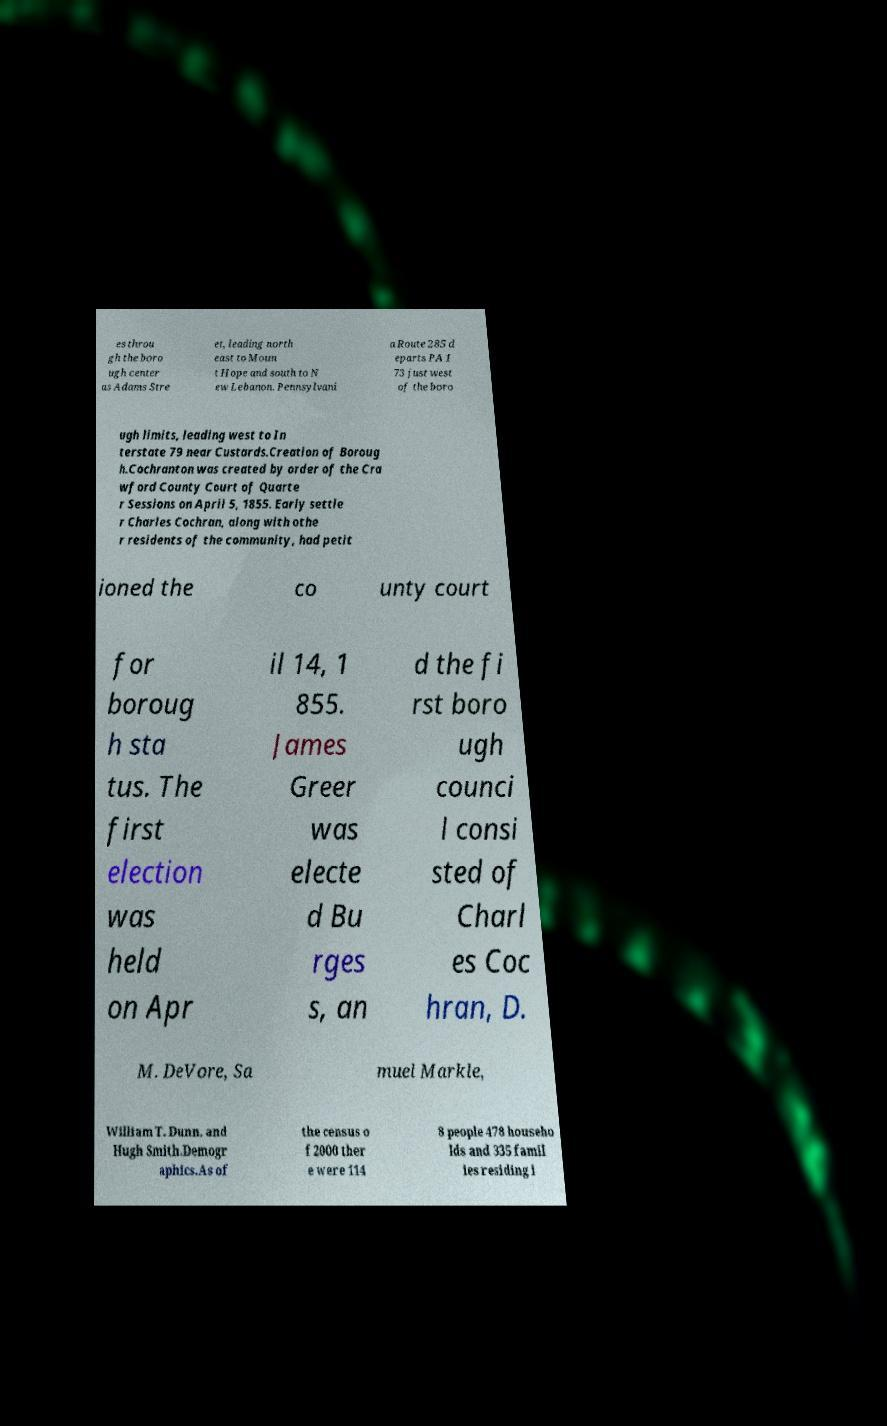Could you extract and type out the text from this image? es throu gh the boro ugh center as Adams Stre et, leading north east to Moun t Hope and south to N ew Lebanon. Pennsylvani a Route 285 d eparts PA 1 73 just west of the boro ugh limits, leading west to In terstate 79 near Custards.Creation of Boroug h.Cochranton was created by order of the Cra wford County Court of Quarte r Sessions on April 5, 1855. Early settle r Charles Cochran, along with othe r residents of the community, had petit ioned the co unty court for boroug h sta tus. The first election was held on Apr il 14, 1 855. James Greer was electe d Bu rges s, an d the fi rst boro ugh counci l consi sted of Charl es Coc hran, D. M. DeVore, Sa muel Markle, William T. Dunn, and Hugh Smith.Demogr aphics.As of the census o f 2000 ther e were 114 8 people 478 househo lds and 335 famil ies residing i 